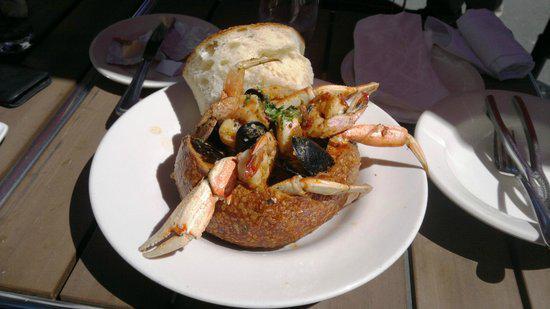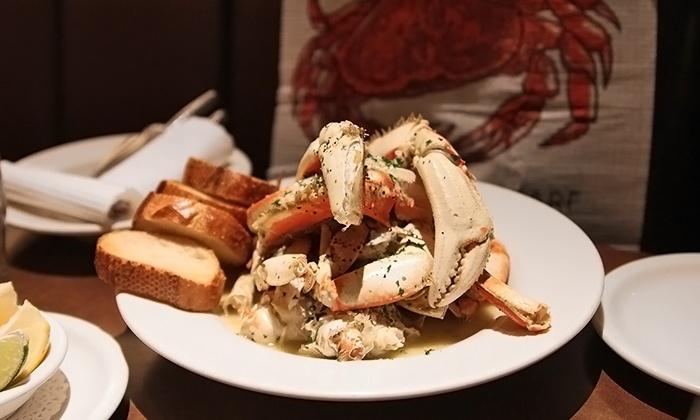The first image is the image on the left, the second image is the image on the right. Given the left and right images, does the statement "Each image contains exactly one round white plate that contains crab [and no other plates containing crab]." hold true? Answer yes or no. Yes. 